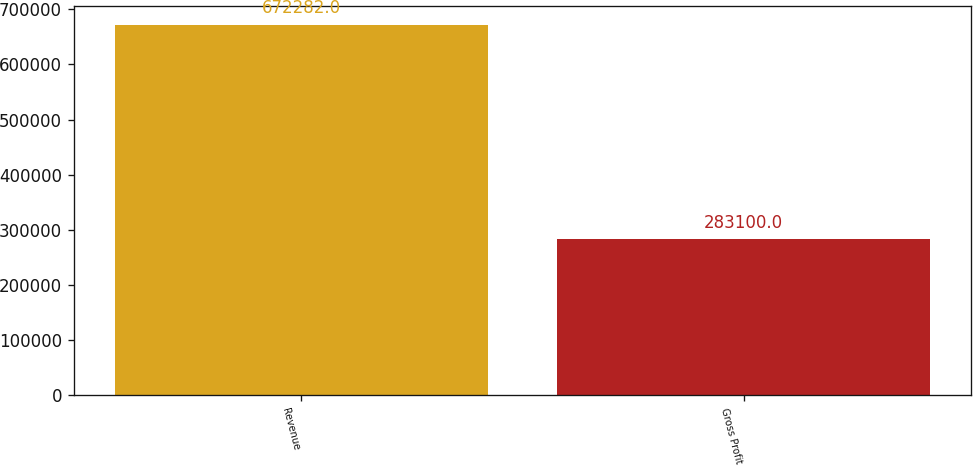Convert chart to OTSL. <chart><loc_0><loc_0><loc_500><loc_500><bar_chart><fcel>Revenue<fcel>Gross Profit<nl><fcel>672282<fcel>283100<nl></chart> 